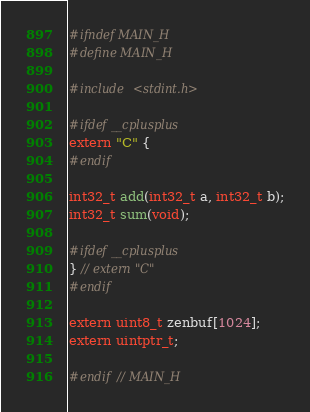Convert code to text. <code><loc_0><loc_0><loc_500><loc_500><_C_>#ifndef MAIN_H
#define MAIN_H

#include <stdint.h>

#ifdef __cplusplus
extern "C" {
#endif

int32_t add(int32_t a, int32_t b);
int32_t sum(void);

#ifdef __cplusplus
} // extern "C"
#endif

extern uint8_t zenbuf[1024];
extern uintptr_t;

#endif // MAIN_H
</code> 